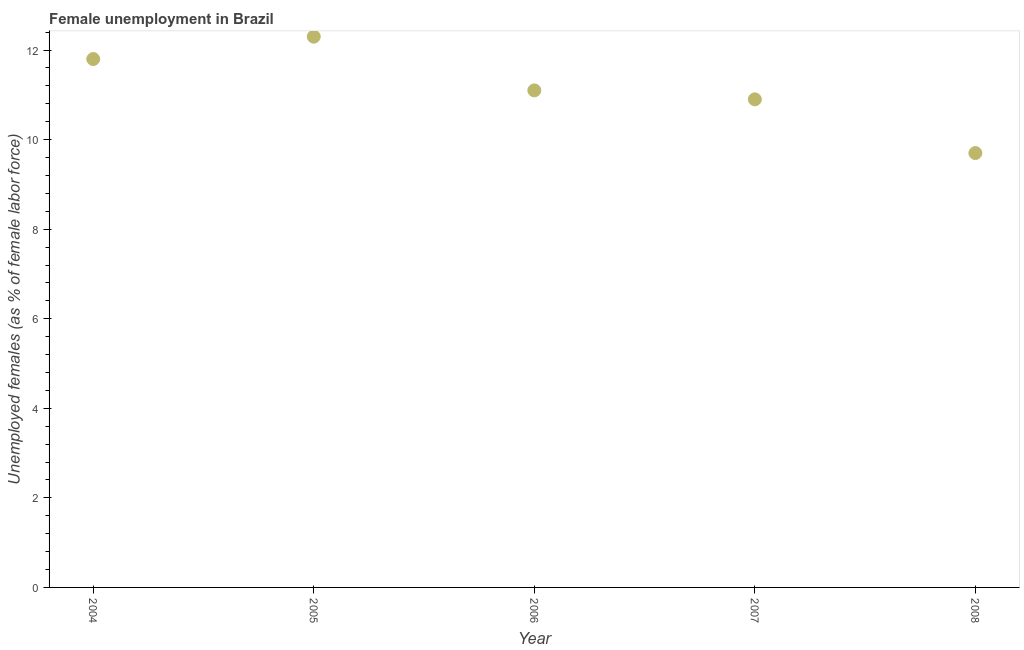What is the unemployed females population in 2005?
Your response must be concise. 12.3. Across all years, what is the maximum unemployed females population?
Your answer should be very brief. 12.3. Across all years, what is the minimum unemployed females population?
Your response must be concise. 9.7. In which year was the unemployed females population maximum?
Ensure brevity in your answer.  2005. In which year was the unemployed females population minimum?
Your answer should be compact. 2008. What is the sum of the unemployed females population?
Your answer should be very brief. 55.8. What is the difference between the unemployed females population in 2006 and 2007?
Give a very brief answer. 0.2. What is the average unemployed females population per year?
Provide a short and direct response. 11.16. What is the median unemployed females population?
Offer a very short reply. 11.1. In how many years, is the unemployed females population greater than 8.4 %?
Your response must be concise. 5. Do a majority of the years between 2005 and 2006 (inclusive) have unemployed females population greater than 2 %?
Your answer should be compact. Yes. What is the ratio of the unemployed females population in 2005 to that in 2006?
Your answer should be compact. 1.11. Is the unemployed females population in 2004 less than that in 2008?
Your answer should be compact. No. Is the difference between the unemployed females population in 2004 and 2005 greater than the difference between any two years?
Offer a terse response. No. Is the sum of the unemployed females population in 2004 and 2006 greater than the maximum unemployed females population across all years?
Make the answer very short. Yes. What is the difference between the highest and the lowest unemployed females population?
Provide a short and direct response. 2.6. In how many years, is the unemployed females population greater than the average unemployed females population taken over all years?
Offer a terse response. 2. Does the unemployed females population monotonically increase over the years?
Your response must be concise. No. How many dotlines are there?
Provide a short and direct response. 1. How many years are there in the graph?
Ensure brevity in your answer.  5. What is the difference between two consecutive major ticks on the Y-axis?
Ensure brevity in your answer.  2. What is the title of the graph?
Your response must be concise. Female unemployment in Brazil. What is the label or title of the X-axis?
Offer a very short reply. Year. What is the label or title of the Y-axis?
Your answer should be compact. Unemployed females (as % of female labor force). What is the Unemployed females (as % of female labor force) in 2004?
Offer a very short reply. 11.8. What is the Unemployed females (as % of female labor force) in 2005?
Keep it short and to the point. 12.3. What is the Unemployed females (as % of female labor force) in 2006?
Keep it short and to the point. 11.1. What is the Unemployed females (as % of female labor force) in 2007?
Your answer should be very brief. 10.9. What is the Unemployed females (as % of female labor force) in 2008?
Offer a very short reply. 9.7. What is the difference between the Unemployed females (as % of female labor force) in 2004 and 2007?
Make the answer very short. 0.9. What is the difference between the Unemployed females (as % of female labor force) in 2004 and 2008?
Provide a short and direct response. 2.1. What is the difference between the Unemployed females (as % of female labor force) in 2005 and 2007?
Offer a very short reply. 1.4. What is the difference between the Unemployed females (as % of female labor force) in 2005 and 2008?
Ensure brevity in your answer.  2.6. What is the difference between the Unemployed females (as % of female labor force) in 2006 and 2007?
Your answer should be compact. 0.2. What is the difference between the Unemployed females (as % of female labor force) in 2006 and 2008?
Give a very brief answer. 1.4. What is the difference between the Unemployed females (as % of female labor force) in 2007 and 2008?
Provide a succinct answer. 1.2. What is the ratio of the Unemployed females (as % of female labor force) in 2004 to that in 2006?
Keep it short and to the point. 1.06. What is the ratio of the Unemployed females (as % of female labor force) in 2004 to that in 2007?
Make the answer very short. 1.08. What is the ratio of the Unemployed females (as % of female labor force) in 2004 to that in 2008?
Your response must be concise. 1.22. What is the ratio of the Unemployed females (as % of female labor force) in 2005 to that in 2006?
Provide a succinct answer. 1.11. What is the ratio of the Unemployed females (as % of female labor force) in 2005 to that in 2007?
Your answer should be very brief. 1.13. What is the ratio of the Unemployed females (as % of female labor force) in 2005 to that in 2008?
Provide a short and direct response. 1.27. What is the ratio of the Unemployed females (as % of female labor force) in 2006 to that in 2007?
Make the answer very short. 1.02. What is the ratio of the Unemployed females (as % of female labor force) in 2006 to that in 2008?
Give a very brief answer. 1.14. What is the ratio of the Unemployed females (as % of female labor force) in 2007 to that in 2008?
Provide a succinct answer. 1.12. 